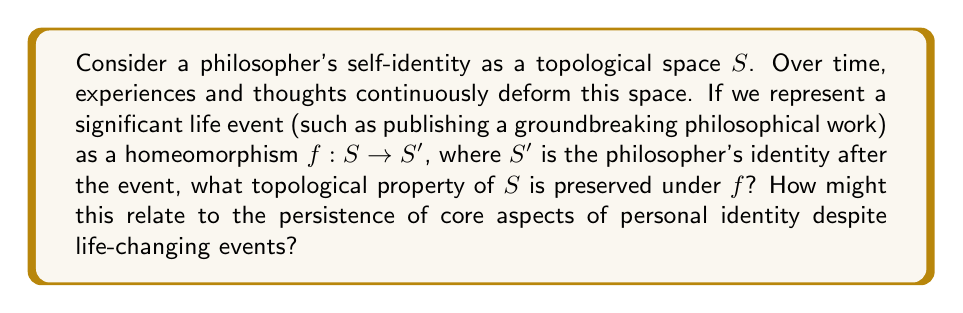Teach me how to tackle this problem. To approach this question, we need to understand the concept of homeomorphism and its implications for personal identity:

1. Homeomorphism in topology:
   A homeomorphism is a continuous function $f: X \rightarrow Y$ between topological spaces with a continuous inverse $f^{-1}: Y \rightarrow X$. Homeomorphisms preserve topological properties.

2. Topological invariants:
   Certain properties of topological spaces remain unchanged under homeomorphisms. These are called topological invariants. Examples include:
   - Connectedness
   - Compactness
   - The Euler characteristic
   - The fundamental group

3. Applying to personal identity:
   In our case, we're considering the philosopher's self-identity as a topological space $S$. The homeomorphism $f: S \rightarrow S'$ represents a significant life event.

4. Preserved properties:
   The key topological property preserved under homeomorphism in this context is the fundamental group, denoted as $\pi_1(S)$.

5. Interpretation:
   The fundamental group represents the "holes" or essential structure of the topological space. In the context of personal identity, this could be interpreted as core beliefs, values, or character traits that persist despite significant life changes.

6. Philosophical implications:
   This preservation of the fundamental group under homeomorphism suggests that while surface-level aspects of identity may change (represented by the continuous deformation), there exists a core structure (fundamental group) that remains invariant. This aligns with philosophical notions of personal identity that posit a persistent self despite external changes.

7. Relevance to the philosopher's persona:
   For a solitary philosopher devoted to deep thinking, this concept resonates with the idea that their core intellectual and philosophical foundations remain intact even as their ideas evolve or gain recognition through published works.
Answer: The topological property of $S$ preserved under the homeomorphism $f$ is its fundamental group, $\pi_1(S)$. This preservation suggests that core aspects of personal identity (represented by the fundamental group) persist despite significant life events, while allowing for continuous evolution of surface-level characteristics. 